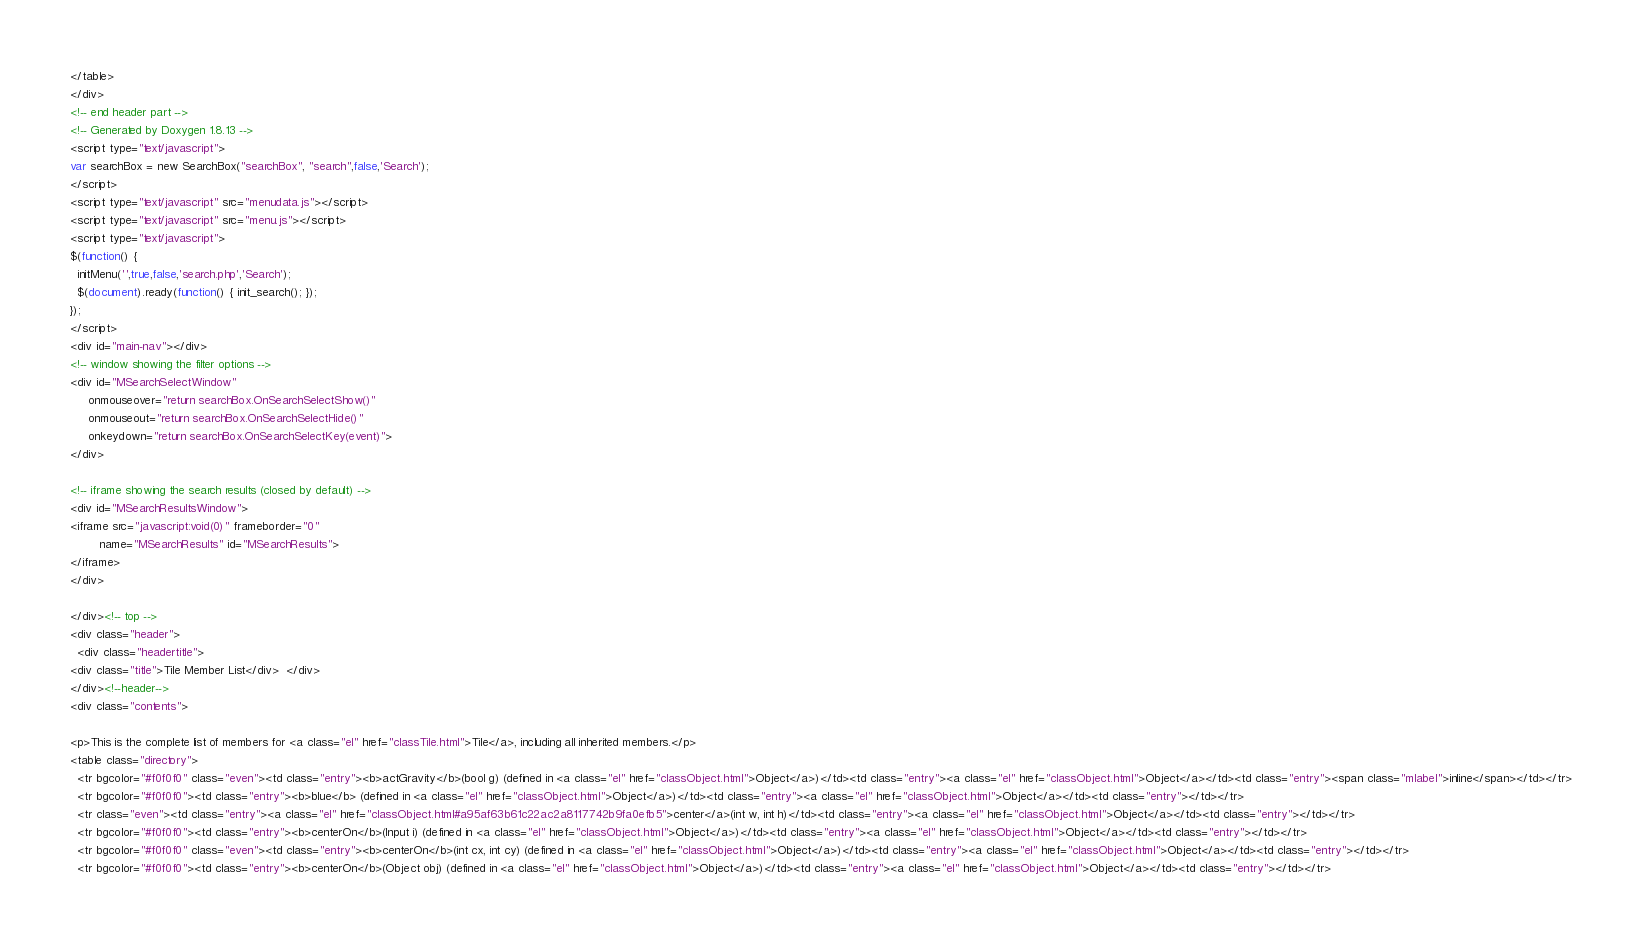Convert code to text. <code><loc_0><loc_0><loc_500><loc_500><_HTML_></table>
</div>
<!-- end header part -->
<!-- Generated by Doxygen 1.8.13 -->
<script type="text/javascript">
var searchBox = new SearchBox("searchBox", "search",false,'Search');
</script>
<script type="text/javascript" src="menudata.js"></script>
<script type="text/javascript" src="menu.js"></script>
<script type="text/javascript">
$(function() {
  initMenu('',true,false,'search.php','Search');
  $(document).ready(function() { init_search(); });
});
</script>
<div id="main-nav"></div>
<!-- window showing the filter options -->
<div id="MSearchSelectWindow"
     onmouseover="return searchBox.OnSearchSelectShow()"
     onmouseout="return searchBox.OnSearchSelectHide()"
     onkeydown="return searchBox.OnSearchSelectKey(event)">
</div>

<!-- iframe showing the search results (closed by default) -->
<div id="MSearchResultsWindow">
<iframe src="javascript:void(0)" frameborder="0" 
        name="MSearchResults" id="MSearchResults">
</iframe>
</div>

</div><!-- top -->
<div class="header">
  <div class="headertitle">
<div class="title">Tile Member List</div>  </div>
</div><!--header-->
<div class="contents">

<p>This is the complete list of members for <a class="el" href="classTile.html">Tile</a>, including all inherited members.</p>
<table class="directory">
  <tr bgcolor="#f0f0f0" class="even"><td class="entry"><b>actGravity</b>(bool g) (defined in <a class="el" href="classObject.html">Object</a>)</td><td class="entry"><a class="el" href="classObject.html">Object</a></td><td class="entry"><span class="mlabel">inline</span></td></tr>
  <tr bgcolor="#f0f0f0"><td class="entry"><b>blue</b> (defined in <a class="el" href="classObject.html">Object</a>)</td><td class="entry"><a class="el" href="classObject.html">Object</a></td><td class="entry"></td></tr>
  <tr class="even"><td class="entry"><a class="el" href="classObject.html#a95af63b61c22ac2a8117742b9fa0efb5">center</a>(int w, int h)</td><td class="entry"><a class="el" href="classObject.html">Object</a></td><td class="entry"></td></tr>
  <tr bgcolor="#f0f0f0"><td class="entry"><b>centerOn</b>(Input i) (defined in <a class="el" href="classObject.html">Object</a>)</td><td class="entry"><a class="el" href="classObject.html">Object</a></td><td class="entry"></td></tr>
  <tr bgcolor="#f0f0f0" class="even"><td class="entry"><b>centerOn</b>(int cx, int cy) (defined in <a class="el" href="classObject.html">Object</a>)</td><td class="entry"><a class="el" href="classObject.html">Object</a></td><td class="entry"></td></tr>
  <tr bgcolor="#f0f0f0"><td class="entry"><b>centerOn</b>(Object obj) (defined in <a class="el" href="classObject.html">Object</a>)</td><td class="entry"><a class="el" href="classObject.html">Object</a></td><td class="entry"></td></tr></code> 